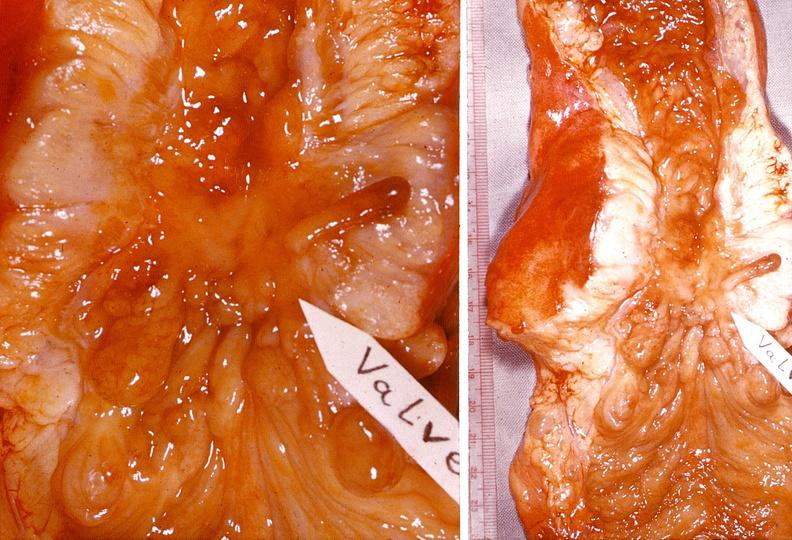does this image show small intestine, regional enteritis?
Answer the question using a single word or phrase. Yes 